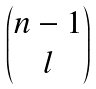<formula> <loc_0><loc_0><loc_500><loc_500>\begin{pmatrix} n - 1 \\ l \end{pmatrix}</formula> 